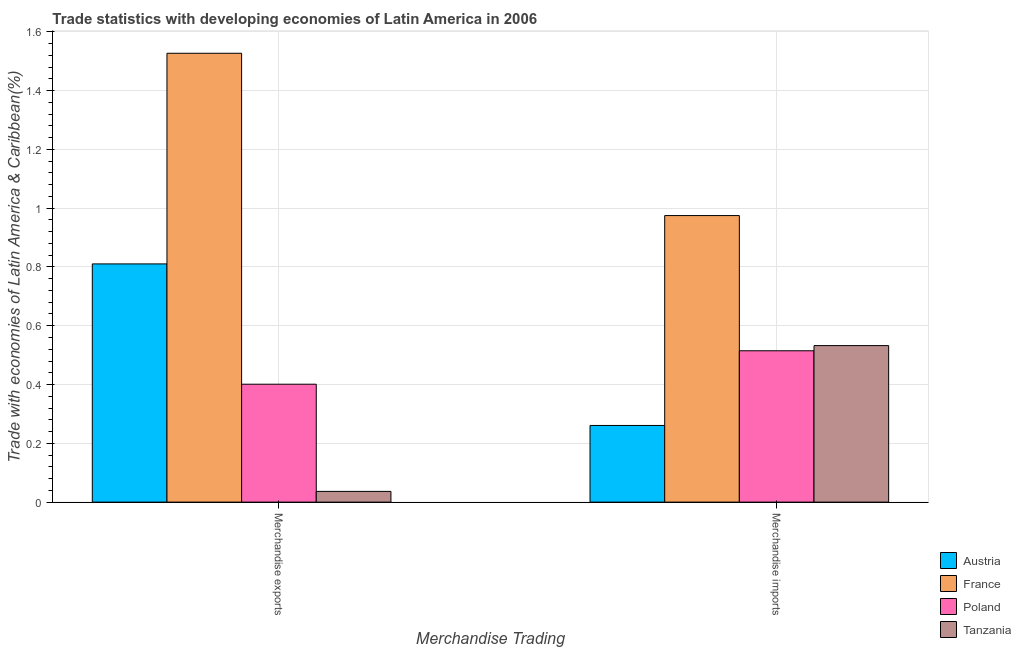How many different coloured bars are there?
Provide a short and direct response. 4. Are the number of bars on each tick of the X-axis equal?
Provide a succinct answer. Yes. How many bars are there on the 1st tick from the right?
Keep it short and to the point. 4. What is the merchandise imports in Austria?
Your answer should be compact. 0.26. Across all countries, what is the maximum merchandise imports?
Keep it short and to the point. 0.97. Across all countries, what is the minimum merchandise imports?
Your response must be concise. 0.26. In which country was the merchandise exports minimum?
Provide a succinct answer. Tanzania. What is the total merchandise imports in the graph?
Offer a very short reply. 2.28. What is the difference between the merchandise imports in Austria and that in Poland?
Offer a terse response. -0.25. What is the difference between the merchandise imports in Austria and the merchandise exports in Poland?
Ensure brevity in your answer.  -0.14. What is the average merchandise imports per country?
Give a very brief answer. 0.57. What is the difference between the merchandise imports and merchandise exports in Austria?
Ensure brevity in your answer.  -0.55. What is the ratio of the merchandise exports in France to that in Tanzania?
Offer a terse response. 41.85. Is the merchandise exports in Poland less than that in Austria?
Provide a succinct answer. Yes. What does the 1st bar from the left in Merchandise exports represents?
Your answer should be compact. Austria. What does the 2nd bar from the right in Merchandise exports represents?
Make the answer very short. Poland. Are all the bars in the graph horizontal?
Ensure brevity in your answer.  No. How many countries are there in the graph?
Ensure brevity in your answer.  4. Does the graph contain grids?
Your response must be concise. Yes. Where does the legend appear in the graph?
Offer a very short reply. Bottom right. How many legend labels are there?
Your response must be concise. 4. How are the legend labels stacked?
Ensure brevity in your answer.  Vertical. What is the title of the graph?
Your answer should be compact. Trade statistics with developing economies of Latin America in 2006. What is the label or title of the X-axis?
Make the answer very short. Merchandise Trading. What is the label or title of the Y-axis?
Offer a terse response. Trade with economies of Latin America & Caribbean(%). What is the Trade with economies of Latin America & Caribbean(%) in Austria in Merchandise exports?
Your answer should be very brief. 0.81. What is the Trade with economies of Latin America & Caribbean(%) in France in Merchandise exports?
Ensure brevity in your answer.  1.53. What is the Trade with economies of Latin America & Caribbean(%) in Poland in Merchandise exports?
Provide a short and direct response. 0.4. What is the Trade with economies of Latin America & Caribbean(%) in Tanzania in Merchandise exports?
Ensure brevity in your answer.  0.04. What is the Trade with economies of Latin America & Caribbean(%) in Austria in Merchandise imports?
Offer a very short reply. 0.26. What is the Trade with economies of Latin America & Caribbean(%) in France in Merchandise imports?
Ensure brevity in your answer.  0.97. What is the Trade with economies of Latin America & Caribbean(%) in Poland in Merchandise imports?
Your response must be concise. 0.51. What is the Trade with economies of Latin America & Caribbean(%) of Tanzania in Merchandise imports?
Your answer should be compact. 0.53. Across all Merchandise Trading, what is the maximum Trade with economies of Latin America & Caribbean(%) of Austria?
Provide a short and direct response. 0.81. Across all Merchandise Trading, what is the maximum Trade with economies of Latin America & Caribbean(%) of France?
Your answer should be compact. 1.53. Across all Merchandise Trading, what is the maximum Trade with economies of Latin America & Caribbean(%) of Poland?
Give a very brief answer. 0.51. Across all Merchandise Trading, what is the maximum Trade with economies of Latin America & Caribbean(%) of Tanzania?
Offer a very short reply. 0.53. Across all Merchandise Trading, what is the minimum Trade with economies of Latin America & Caribbean(%) of Austria?
Provide a succinct answer. 0.26. Across all Merchandise Trading, what is the minimum Trade with economies of Latin America & Caribbean(%) in France?
Make the answer very short. 0.97. Across all Merchandise Trading, what is the minimum Trade with economies of Latin America & Caribbean(%) of Poland?
Keep it short and to the point. 0.4. Across all Merchandise Trading, what is the minimum Trade with economies of Latin America & Caribbean(%) in Tanzania?
Your response must be concise. 0.04. What is the total Trade with economies of Latin America & Caribbean(%) in Austria in the graph?
Provide a succinct answer. 1.07. What is the total Trade with economies of Latin America & Caribbean(%) in France in the graph?
Make the answer very short. 2.5. What is the total Trade with economies of Latin America & Caribbean(%) in Poland in the graph?
Offer a terse response. 0.92. What is the total Trade with economies of Latin America & Caribbean(%) in Tanzania in the graph?
Your answer should be very brief. 0.57. What is the difference between the Trade with economies of Latin America & Caribbean(%) in Austria in Merchandise exports and that in Merchandise imports?
Ensure brevity in your answer.  0.55. What is the difference between the Trade with economies of Latin America & Caribbean(%) of France in Merchandise exports and that in Merchandise imports?
Your response must be concise. 0.55. What is the difference between the Trade with economies of Latin America & Caribbean(%) in Poland in Merchandise exports and that in Merchandise imports?
Make the answer very short. -0.11. What is the difference between the Trade with economies of Latin America & Caribbean(%) of Tanzania in Merchandise exports and that in Merchandise imports?
Your response must be concise. -0.5. What is the difference between the Trade with economies of Latin America & Caribbean(%) of Austria in Merchandise exports and the Trade with economies of Latin America & Caribbean(%) of France in Merchandise imports?
Offer a very short reply. -0.16. What is the difference between the Trade with economies of Latin America & Caribbean(%) in Austria in Merchandise exports and the Trade with economies of Latin America & Caribbean(%) in Poland in Merchandise imports?
Ensure brevity in your answer.  0.3. What is the difference between the Trade with economies of Latin America & Caribbean(%) in Austria in Merchandise exports and the Trade with economies of Latin America & Caribbean(%) in Tanzania in Merchandise imports?
Provide a short and direct response. 0.28. What is the difference between the Trade with economies of Latin America & Caribbean(%) of France in Merchandise exports and the Trade with economies of Latin America & Caribbean(%) of Poland in Merchandise imports?
Offer a very short reply. 1.01. What is the difference between the Trade with economies of Latin America & Caribbean(%) in France in Merchandise exports and the Trade with economies of Latin America & Caribbean(%) in Tanzania in Merchandise imports?
Your response must be concise. 0.99. What is the difference between the Trade with economies of Latin America & Caribbean(%) in Poland in Merchandise exports and the Trade with economies of Latin America & Caribbean(%) in Tanzania in Merchandise imports?
Ensure brevity in your answer.  -0.13. What is the average Trade with economies of Latin America & Caribbean(%) in Austria per Merchandise Trading?
Offer a terse response. 0.54. What is the average Trade with economies of Latin America & Caribbean(%) in France per Merchandise Trading?
Ensure brevity in your answer.  1.25. What is the average Trade with economies of Latin America & Caribbean(%) in Poland per Merchandise Trading?
Your response must be concise. 0.46. What is the average Trade with economies of Latin America & Caribbean(%) in Tanzania per Merchandise Trading?
Ensure brevity in your answer.  0.28. What is the difference between the Trade with economies of Latin America & Caribbean(%) in Austria and Trade with economies of Latin America & Caribbean(%) in France in Merchandise exports?
Your answer should be very brief. -0.72. What is the difference between the Trade with economies of Latin America & Caribbean(%) in Austria and Trade with economies of Latin America & Caribbean(%) in Poland in Merchandise exports?
Your answer should be very brief. 0.41. What is the difference between the Trade with economies of Latin America & Caribbean(%) in Austria and Trade with economies of Latin America & Caribbean(%) in Tanzania in Merchandise exports?
Provide a succinct answer. 0.77. What is the difference between the Trade with economies of Latin America & Caribbean(%) of France and Trade with economies of Latin America & Caribbean(%) of Poland in Merchandise exports?
Give a very brief answer. 1.13. What is the difference between the Trade with economies of Latin America & Caribbean(%) in France and Trade with economies of Latin America & Caribbean(%) in Tanzania in Merchandise exports?
Your answer should be compact. 1.49. What is the difference between the Trade with economies of Latin America & Caribbean(%) in Poland and Trade with economies of Latin America & Caribbean(%) in Tanzania in Merchandise exports?
Your answer should be very brief. 0.36. What is the difference between the Trade with economies of Latin America & Caribbean(%) in Austria and Trade with economies of Latin America & Caribbean(%) in France in Merchandise imports?
Offer a terse response. -0.71. What is the difference between the Trade with economies of Latin America & Caribbean(%) of Austria and Trade with economies of Latin America & Caribbean(%) of Poland in Merchandise imports?
Ensure brevity in your answer.  -0.25. What is the difference between the Trade with economies of Latin America & Caribbean(%) of Austria and Trade with economies of Latin America & Caribbean(%) of Tanzania in Merchandise imports?
Offer a terse response. -0.27. What is the difference between the Trade with economies of Latin America & Caribbean(%) in France and Trade with economies of Latin America & Caribbean(%) in Poland in Merchandise imports?
Give a very brief answer. 0.46. What is the difference between the Trade with economies of Latin America & Caribbean(%) of France and Trade with economies of Latin America & Caribbean(%) of Tanzania in Merchandise imports?
Ensure brevity in your answer.  0.44. What is the difference between the Trade with economies of Latin America & Caribbean(%) of Poland and Trade with economies of Latin America & Caribbean(%) of Tanzania in Merchandise imports?
Offer a very short reply. -0.02. What is the ratio of the Trade with economies of Latin America & Caribbean(%) in Austria in Merchandise exports to that in Merchandise imports?
Provide a short and direct response. 3.11. What is the ratio of the Trade with economies of Latin America & Caribbean(%) of France in Merchandise exports to that in Merchandise imports?
Provide a short and direct response. 1.57. What is the ratio of the Trade with economies of Latin America & Caribbean(%) in Poland in Merchandise exports to that in Merchandise imports?
Provide a short and direct response. 0.78. What is the ratio of the Trade with economies of Latin America & Caribbean(%) of Tanzania in Merchandise exports to that in Merchandise imports?
Your answer should be compact. 0.07. What is the difference between the highest and the second highest Trade with economies of Latin America & Caribbean(%) in Austria?
Provide a succinct answer. 0.55. What is the difference between the highest and the second highest Trade with economies of Latin America & Caribbean(%) in France?
Ensure brevity in your answer.  0.55. What is the difference between the highest and the second highest Trade with economies of Latin America & Caribbean(%) of Poland?
Provide a succinct answer. 0.11. What is the difference between the highest and the second highest Trade with economies of Latin America & Caribbean(%) of Tanzania?
Your response must be concise. 0.5. What is the difference between the highest and the lowest Trade with economies of Latin America & Caribbean(%) of Austria?
Your answer should be compact. 0.55. What is the difference between the highest and the lowest Trade with economies of Latin America & Caribbean(%) in France?
Provide a succinct answer. 0.55. What is the difference between the highest and the lowest Trade with economies of Latin America & Caribbean(%) of Poland?
Ensure brevity in your answer.  0.11. What is the difference between the highest and the lowest Trade with economies of Latin America & Caribbean(%) of Tanzania?
Ensure brevity in your answer.  0.5. 